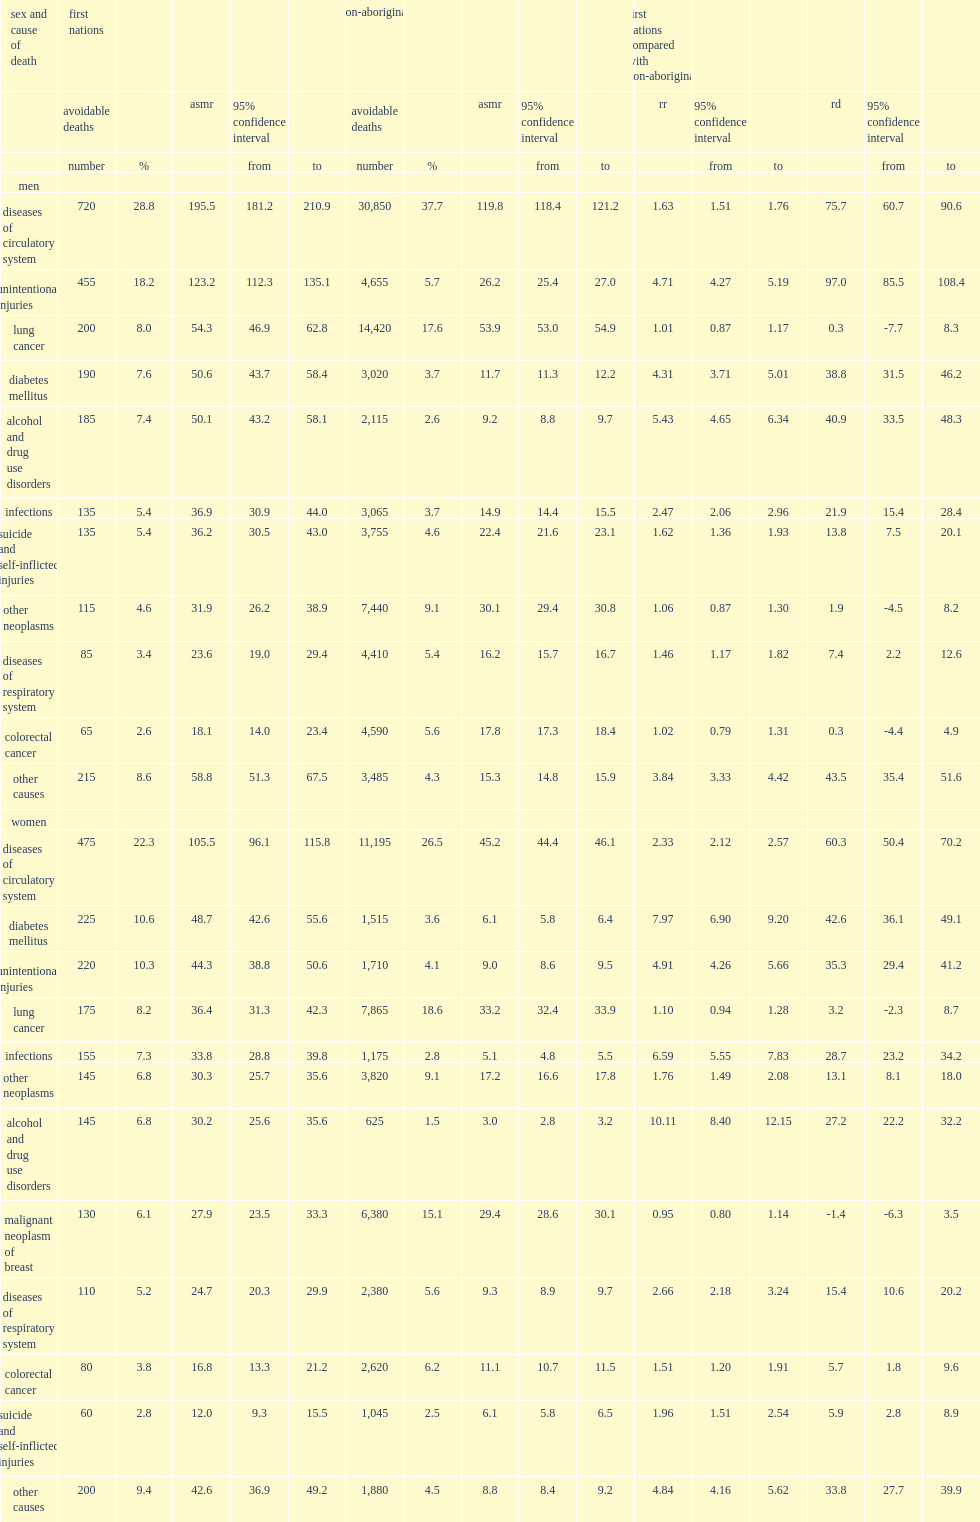Which type of men were more likely to die from alcohol and drug use disorders, first nations or non-aboriginal? First nations. Which type of men were more likely to die from unintentional injuries, first nations or non-aboriginal? First nations. Which type of men were more likely to die from diabetes mellitus, first nations or non-aboriginal? First nations. Which type of women's relative risks of death for alcohol and drug use disorders were higher according to asmr, first nations or non-aboriginal? First nations. Which type of women's relative risks of death for diabetes mellitus were higher according to asmr, first nations or non-aboriginal? First nations. Which type of women's relative risks of death for infections were higher according to asmr, first nations or non-aboriginal? First nations. Which type of women's relative risks of death for unintentional injuries were higher according to asmr, first nations or non-aboriginal? First nations. 